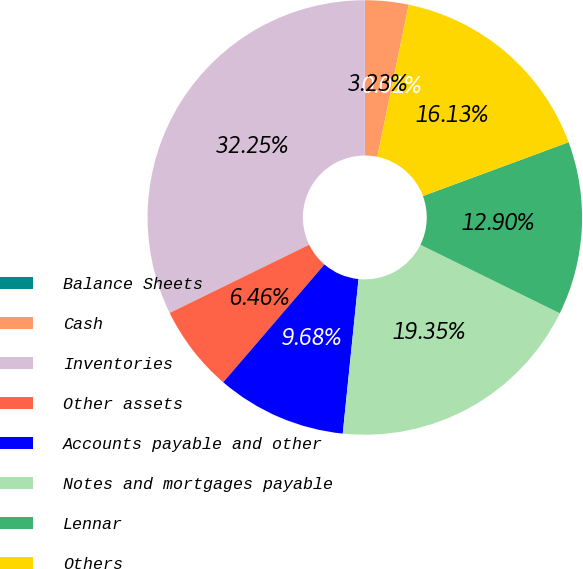Convert chart. <chart><loc_0><loc_0><loc_500><loc_500><pie_chart><fcel>Balance Sheets<fcel>Cash<fcel>Inventories<fcel>Other assets<fcel>Accounts payable and other<fcel>Notes and mortgages payable<fcel>Lennar<fcel>Others<nl><fcel>0.01%<fcel>3.23%<fcel>32.25%<fcel>6.46%<fcel>9.68%<fcel>19.35%<fcel>12.9%<fcel>16.13%<nl></chart> 